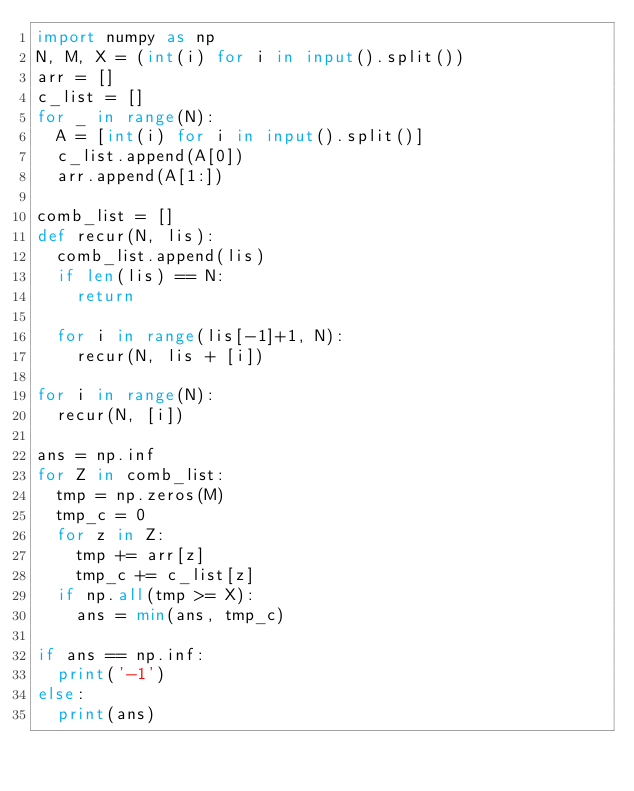Convert code to text. <code><loc_0><loc_0><loc_500><loc_500><_Python_>import numpy as np
N, M, X = (int(i) for i in input().split())  
arr = []
c_list = []
for _ in range(N):
  A = [int(i) for i in input().split()] 
  c_list.append(A[0])
  arr.append(A[1:])

comb_list = []
def recur(N, lis):
  comb_list.append(lis)
  if len(lis) == N:
    return
  
  for i in range(lis[-1]+1, N):
    recur(N, lis + [i])  

for i in range(N):
  recur(N, [i])

ans = np.inf
for Z in comb_list:
  tmp = np.zeros(M)
  tmp_c = 0
  for z in Z:
    tmp += arr[z]
    tmp_c += c_list[z]
  if np.all(tmp >= X):
    ans = min(ans, tmp_c)

if ans == np.inf:
  print('-1')
else:
  print(ans)</code> 